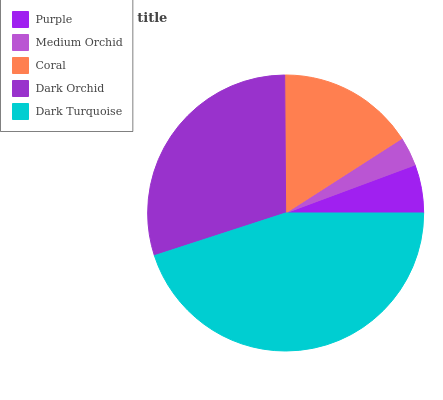Is Medium Orchid the minimum?
Answer yes or no. Yes. Is Dark Turquoise the maximum?
Answer yes or no. Yes. Is Coral the minimum?
Answer yes or no. No. Is Coral the maximum?
Answer yes or no. No. Is Coral greater than Medium Orchid?
Answer yes or no. Yes. Is Medium Orchid less than Coral?
Answer yes or no. Yes. Is Medium Orchid greater than Coral?
Answer yes or no. No. Is Coral less than Medium Orchid?
Answer yes or no. No. Is Coral the high median?
Answer yes or no. Yes. Is Coral the low median?
Answer yes or no. Yes. Is Medium Orchid the high median?
Answer yes or no. No. Is Medium Orchid the low median?
Answer yes or no. No. 